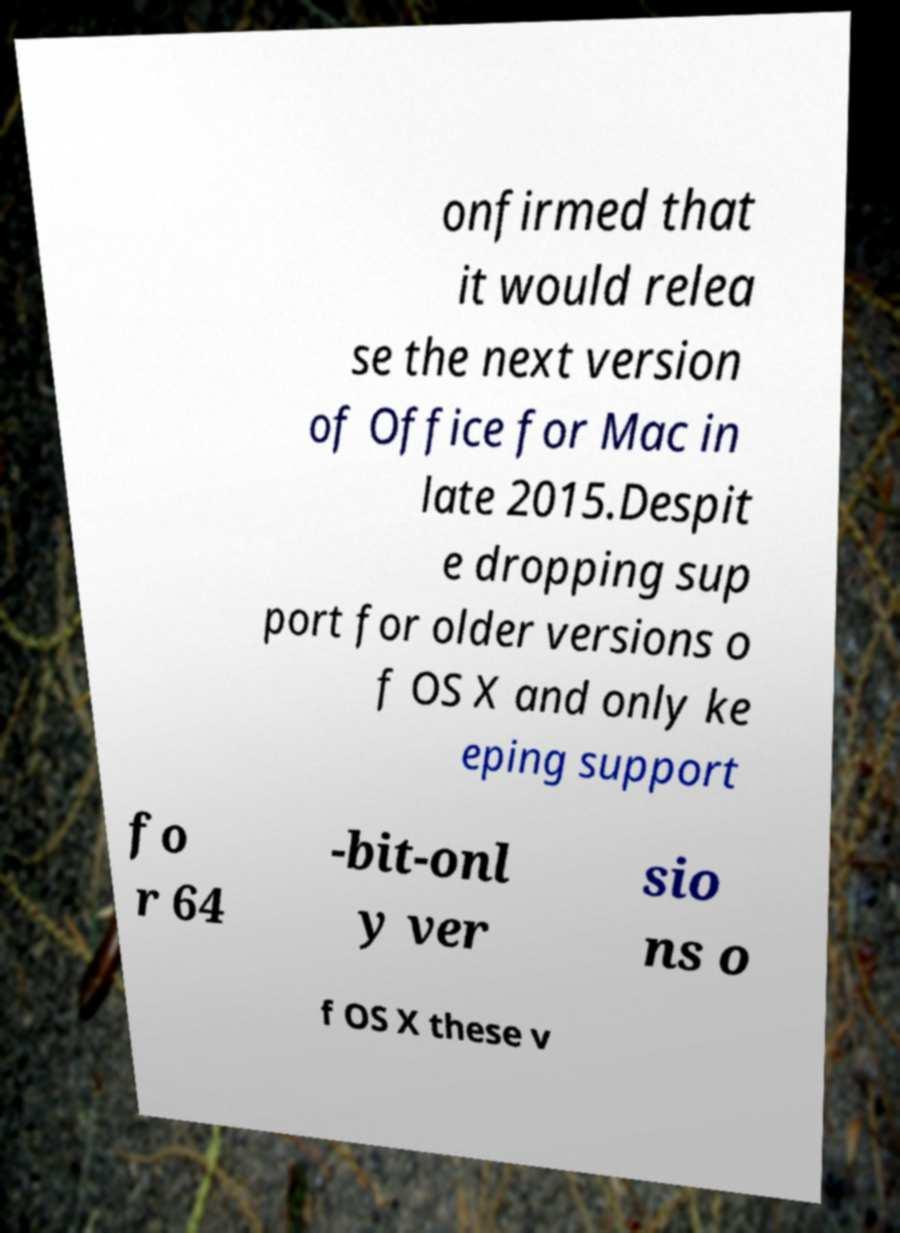Can you accurately transcribe the text from the provided image for me? onfirmed that it would relea se the next version of Office for Mac in late 2015.Despit e dropping sup port for older versions o f OS X and only ke eping support fo r 64 -bit-onl y ver sio ns o f OS X these v 